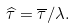<formula> <loc_0><loc_0><loc_500><loc_500>\widehat { \tau } = \overline { \tau } / \lambda .</formula> 